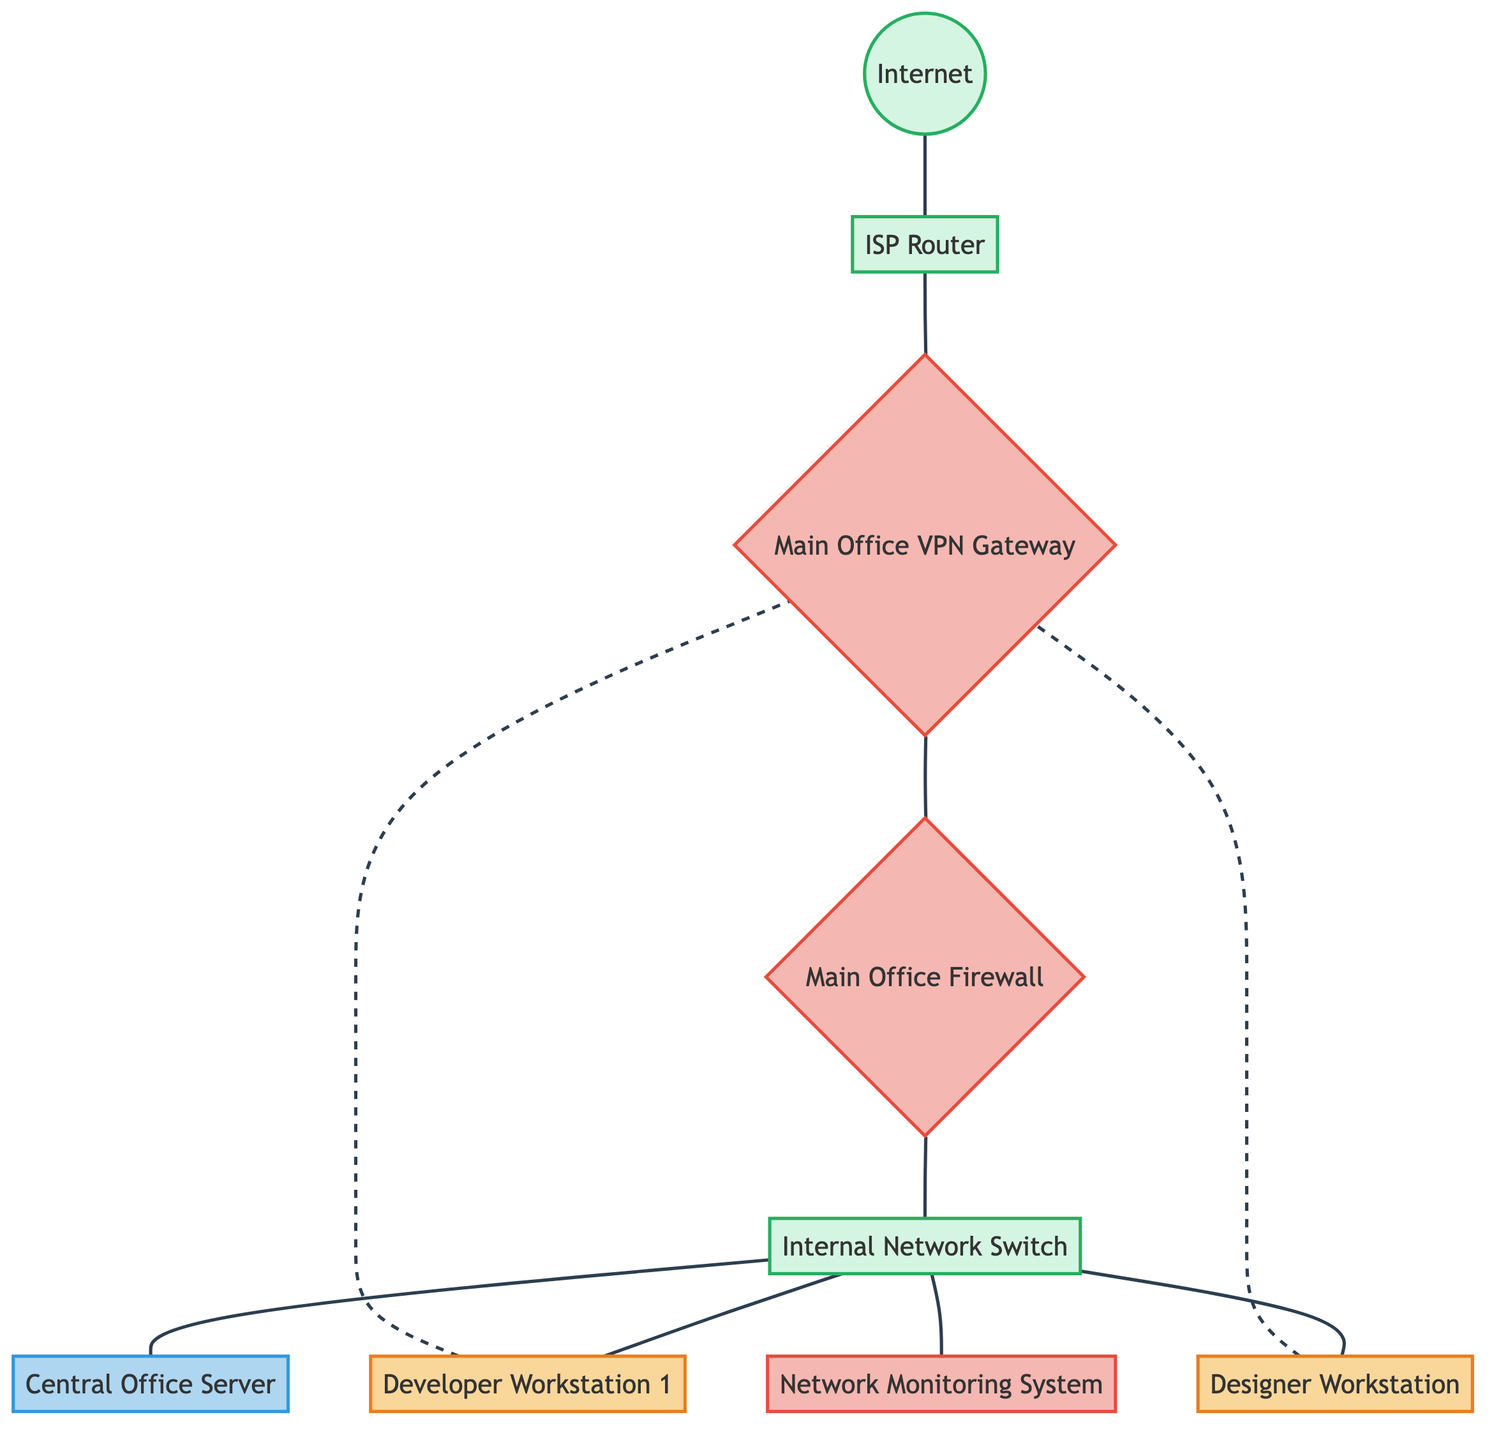What type of device is "Developer Workstation 1"? "Developer Workstation 1" is categorized as a workstation in the diagram, which is specifically labeled and defined.
Answer: Workstation How many workstations are present in the diagram? The diagram explicitly shows two nodes classified as workstations: "Developer Workstation 1" and "Designer Workstation".
Answer: 2 What is the function of the "Main Office Firewall"? The "Main Office Firewall" acts as a security device securing the internal network according to predefined security policies.
Answer: Securing internal network Which device provides connectivity to the "Main Office VPN Gateway"? The "ISP Router" provides internet connectivity to the "Main Office VPN Gateway" as indicated by the flow from the internet to the router and then to the VPN.
Answer: ISP Router Explain the connection between the workstations and the VPN. Both workstations, "Developer Workstation 1" and "Designer Workstation", are depicted with dashed lines connecting to the "Main Office VPN Gateway", showing that they connect remotely through the VPN for secure access.
Answer: Dashed lines indicate VPN connection What is the primary purpose of the "Network Monitoring System"? The "Network Monitoring System" monitors VPN usage and network health, as described in its role in the network diagram.
Answer: Monitoring VPN usage and network health Which device is directly connected to the "Central Office Server"? The "Internal Network Switch" is the device that directly connects to the "Central Office Server", linking it with other internal devices including workstations.
Answer: Internal Network Switch What is the relationship between the "ISP Router" and the "Internet"? The "ISP Router" is connected to the "Internet," indicating that it serves as the entry point for external internet traffic entering the secure network.
Answer: Connectivity What type of connection is used between the workstations and the VPN? The workstations are depicted with dashed lines to the "Main Office VPN Gateway," representing a non-solid, indirect connection typical for secure VPN access.
Answer: Dashed lines (VPN connection) 